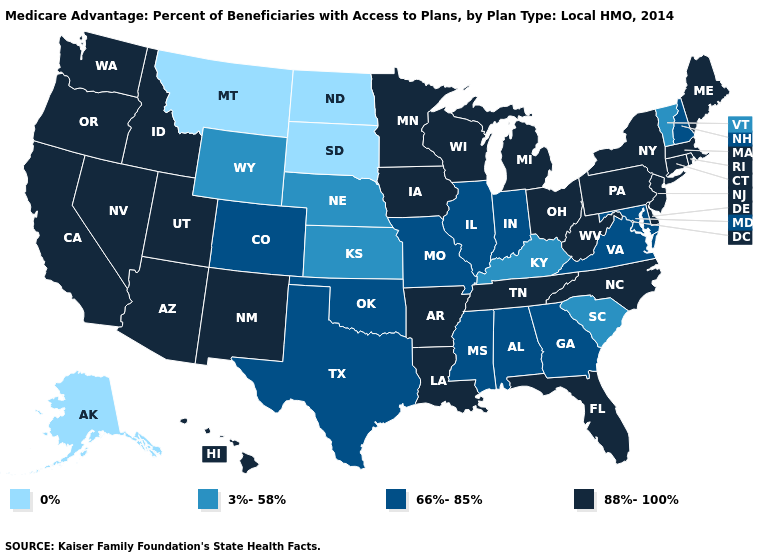What is the value of New Mexico?
Answer briefly. 88%-100%. What is the value of South Dakota?
Quick response, please. 0%. Does Vermont have the lowest value in the USA?
Write a very short answer. No. Which states have the lowest value in the Northeast?
Short answer required. Vermont. What is the value of Arizona?
Quick response, please. 88%-100%. Does New Mexico have the same value as Illinois?
Answer briefly. No. Name the states that have a value in the range 66%-85%?
Give a very brief answer. Colorado, Georgia, Illinois, Indiana, Maryland, Missouri, Mississippi, New Hampshire, Oklahoma, Texas, Virginia, Alabama. Among the states that border Utah , which have the highest value?
Short answer required. Idaho, New Mexico, Nevada, Arizona. Does New Hampshire have a lower value than Idaho?
Concise answer only. Yes. Among the states that border South Carolina , does North Carolina have the lowest value?
Concise answer only. No. Name the states that have a value in the range 0%?
Answer briefly. Montana, North Dakota, South Dakota, Alaska. Among the states that border Vermont , which have the lowest value?
Short answer required. New Hampshire. Does Florida have the highest value in the South?
Give a very brief answer. Yes. Which states have the lowest value in the USA?
Concise answer only. Montana, North Dakota, South Dakota, Alaska. 